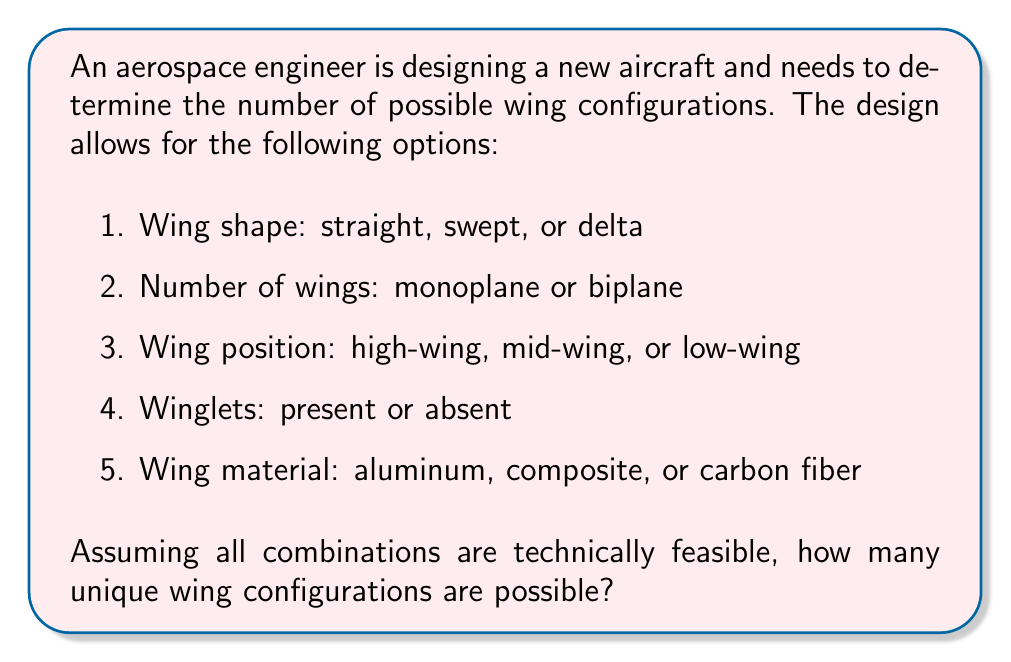Show me your answer to this math problem. To solve this problem, we need to use the multiplication principle of counting. This principle states that if we have several independent choices, the total number of possible outcomes is the product of the number of possibilities for each choice.

Let's break down the options:

1. Wing shape: 3 options (straight, swept, or delta)
2. Number of wings: 2 options (monoplane or biplane)
3. Wing position: 3 options (high-wing, mid-wing, or low-wing)
4. Winglets: 2 options (present or absent)
5. Wing material: 3 options (aluminum, composite, or carbon fiber)

Now, we multiply these numbers together:

$$ \text{Total configurations} = 3 \times 2 \times 3 \times 2 \times 3 $$

$$ = 3^2 \times 2^2 \times 3 $$

$$ = 9 \times 4 \times 3 $$

$$ = 36 \times 3 $$

$$ = 108 $$

Therefore, there are 108 possible unique wing configurations based on the given options.

This approach allows the aerospace engineer to systematically consider all possible combinations, which is crucial for optimizing aircraft performance through theoretical analysis of various wing designs.
Answer: 108 possible wing configurations 